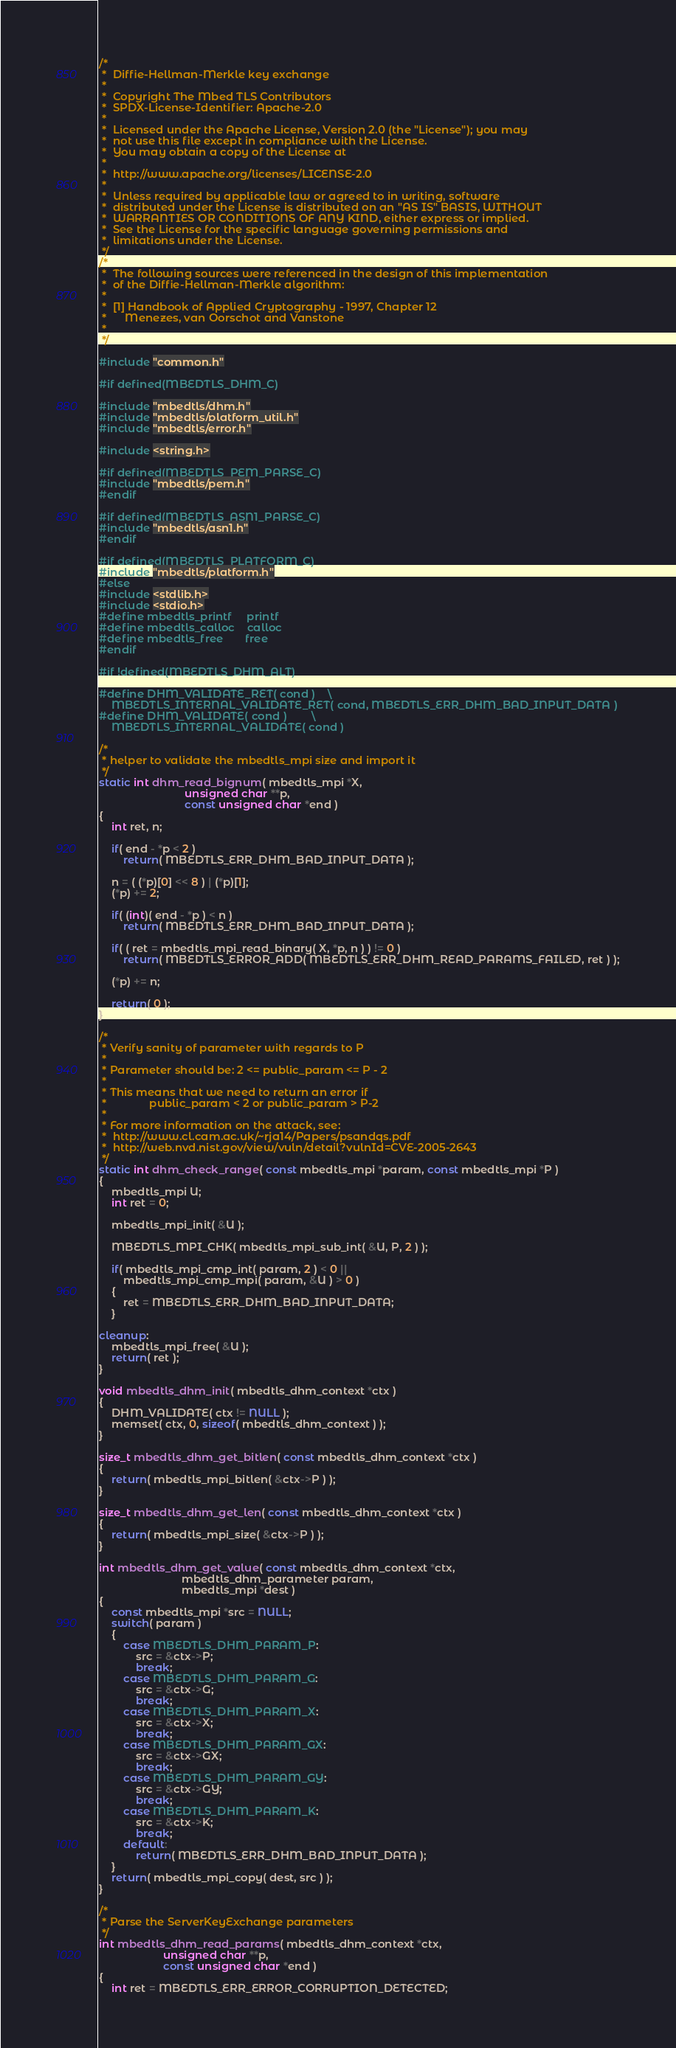Convert code to text. <code><loc_0><loc_0><loc_500><loc_500><_C_>/*
 *  Diffie-Hellman-Merkle key exchange
 *
 *  Copyright The Mbed TLS Contributors
 *  SPDX-License-Identifier: Apache-2.0
 *
 *  Licensed under the Apache License, Version 2.0 (the "License"); you may
 *  not use this file except in compliance with the License.
 *  You may obtain a copy of the License at
 *
 *  http://www.apache.org/licenses/LICENSE-2.0
 *
 *  Unless required by applicable law or agreed to in writing, software
 *  distributed under the License is distributed on an "AS IS" BASIS, WITHOUT
 *  WARRANTIES OR CONDITIONS OF ANY KIND, either express or implied.
 *  See the License for the specific language governing permissions and
 *  limitations under the License.
 */
/*
 *  The following sources were referenced in the design of this implementation
 *  of the Diffie-Hellman-Merkle algorithm:
 *
 *  [1] Handbook of Applied Cryptography - 1997, Chapter 12
 *      Menezes, van Oorschot and Vanstone
 *
 */

#include "common.h"

#if defined(MBEDTLS_DHM_C)

#include "mbedtls/dhm.h"
#include "mbedtls/platform_util.h"
#include "mbedtls/error.h"

#include <string.h>

#if defined(MBEDTLS_PEM_PARSE_C)
#include "mbedtls/pem.h"
#endif

#if defined(MBEDTLS_ASN1_PARSE_C)
#include "mbedtls/asn1.h"
#endif

#if defined(MBEDTLS_PLATFORM_C)
#include "mbedtls/platform.h"
#else
#include <stdlib.h>
#include <stdio.h>
#define mbedtls_printf     printf
#define mbedtls_calloc    calloc
#define mbedtls_free       free
#endif

#if !defined(MBEDTLS_DHM_ALT)

#define DHM_VALIDATE_RET( cond )    \
    MBEDTLS_INTERNAL_VALIDATE_RET( cond, MBEDTLS_ERR_DHM_BAD_INPUT_DATA )
#define DHM_VALIDATE( cond )        \
    MBEDTLS_INTERNAL_VALIDATE( cond )

/*
 * helper to validate the mbedtls_mpi size and import it
 */
static int dhm_read_bignum( mbedtls_mpi *X,
                            unsigned char **p,
                            const unsigned char *end )
{
    int ret, n;

    if( end - *p < 2 )
        return( MBEDTLS_ERR_DHM_BAD_INPUT_DATA );

    n = ( (*p)[0] << 8 ) | (*p)[1];
    (*p) += 2;

    if( (int)( end - *p ) < n )
        return( MBEDTLS_ERR_DHM_BAD_INPUT_DATA );

    if( ( ret = mbedtls_mpi_read_binary( X, *p, n ) ) != 0 )
        return( MBEDTLS_ERROR_ADD( MBEDTLS_ERR_DHM_READ_PARAMS_FAILED, ret ) );

    (*p) += n;

    return( 0 );
}

/*
 * Verify sanity of parameter with regards to P
 *
 * Parameter should be: 2 <= public_param <= P - 2
 *
 * This means that we need to return an error if
 *              public_param < 2 or public_param > P-2
 *
 * For more information on the attack, see:
 *  http://www.cl.cam.ac.uk/~rja14/Papers/psandqs.pdf
 *  http://web.nvd.nist.gov/view/vuln/detail?vulnId=CVE-2005-2643
 */
static int dhm_check_range( const mbedtls_mpi *param, const mbedtls_mpi *P )
{
    mbedtls_mpi U;
    int ret = 0;

    mbedtls_mpi_init( &U );

    MBEDTLS_MPI_CHK( mbedtls_mpi_sub_int( &U, P, 2 ) );

    if( mbedtls_mpi_cmp_int( param, 2 ) < 0 ||
        mbedtls_mpi_cmp_mpi( param, &U ) > 0 )
    {
        ret = MBEDTLS_ERR_DHM_BAD_INPUT_DATA;
    }

cleanup:
    mbedtls_mpi_free( &U );
    return( ret );
}

void mbedtls_dhm_init( mbedtls_dhm_context *ctx )
{
    DHM_VALIDATE( ctx != NULL );
    memset( ctx, 0, sizeof( mbedtls_dhm_context ) );
}

size_t mbedtls_dhm_get_bitlen( const mbedtls_dhm_context *ctx )
{
    return( mbedtls_mpi_bitlen( &ctx->P ) );
}

size_t mbedtls_dhm_get_len( const mbedtls_dhm_context *ctx )
{
    return( mbedtls_mpi_size( &ctx->P ) );
}

int mbedtls_dhm_get_value( const mbedtls_dhm_context *ctx,
                           mbedtls_dhm_parameter param,
                           mbedtls_mpi *dest )
{
    const mbedtls_mpi *src = NULL;
    switch( param )
    {
        case MBEDTLS_DHM_PARAM_P:
            src = &ctx->P;
            break;
        case MBEDTLS_DHM_PARAM_G:
            src = &ctx->G;
            break;
        case MBEDTLS_DHM_PARAM_X:
            src = &ctx->X;
            break;
        case MBEDTLS_DHM_PARAM_GX:
            src = &ctx->GX;
            break;
        case MBEDTLS_DHM_PARAM_GY:
            src = &ctx->GY;
            break;
        case MBEDTLS_DHM_PARAM_K:
            src = &ctx->K;
            break;
        default:
            return( MBEDTLS_ERR_DHM_BAD_INPUT_DATA );
    }
    return( mbedtls_mpi_copy( dest, src ) );
}

/*
 * Parse the ServerKeyExchange parameters
 */
int mbedtls_dhm_read_params( mbedtls_dhm_context *ctx,
                     unsigned char **p,
                     const unsigned char *end )
{
    int ret = MBEDTLS_ERR_ERROR_CORRUPTION_DETECTED;</code> 